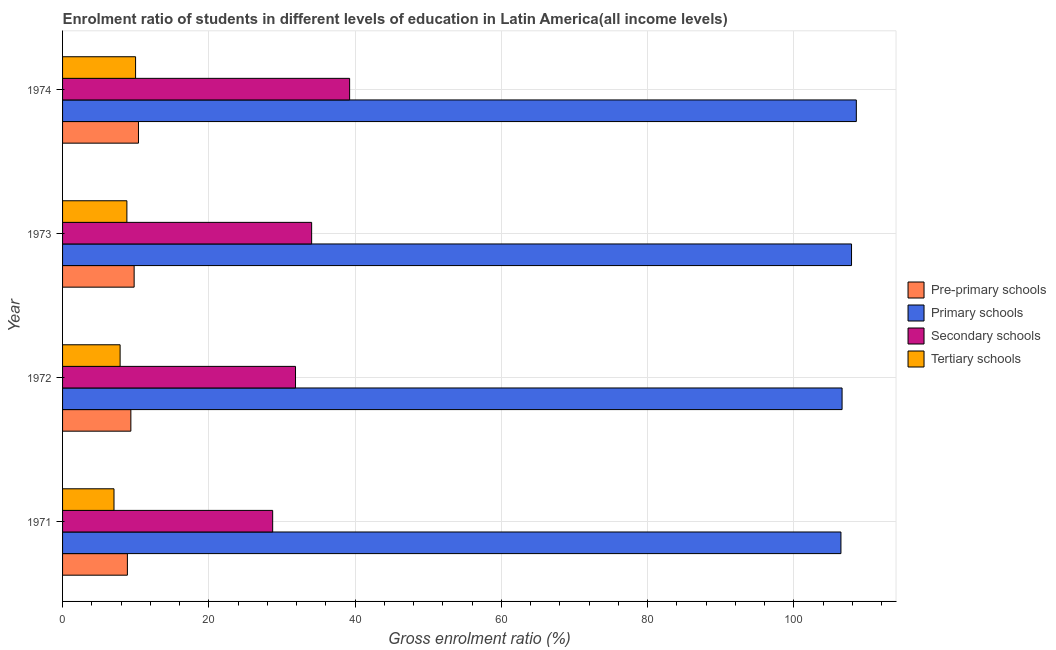How many different coloured bars are there?
Ensure brevity in your answer.  4. Are the number of bars per tick equal to the number of legend labels?
Give a very brief answer. Yes. Are the number of bars on each tick of the Y-axis equal?
Your answer should be compact. Yes. What is the label of the 1st group of bars from the top?
Ensure brevity in your answer.  1974. What is the gross enrolment ratio in pre-primary schools in 1972?
Offer a very short reply. 9.34. Across all years, what is the maximum gross enrolment ratio in tertiary schools?
Provide a succinct answer. 9.98. Across all years, what is the minimum gross enrolment ratio in pre-primary schools?
Provide a succinct answer. 8.86. In which year was the gross enrolment ratio in pre-primary schools maximum?
Your answer should be compact. 1974. In which year was the gross enrolment ratio in tertiary schools minimum?
Offer a terse response. 1971. What is the total gross enrolment ratio in primary schools in the graph?
Offer a terse response. 429.39. What is the difference between the gross enrolment ratio in pre-primary schools in 1972 and that in 1973?
Make the answer very short. -0.45. What is the difference between the gross enrolment ratio in tertiary schools in 1972 and the gross enrolment ratio in primary schools in 1971?
Provide a short and direct response. -98.55. What is the average gross enrolment ratio in pre-primary schools per year?
Offer a very short reply. 9.59. In the year 1973, what is the difference between the gross enrolment ratio in secondary schools and gross enrolment ratio in tertiary schools?
Provide a short and direct response. 25.26. In how many years, is the gross enrolment ratio in secondary schools greater than 56 %?
Your answer should be very brief. 0. Is the gross enrolment ratio in secondary schools in 1971 less than that in 1973?
Make the answer very short. Yes. What is the difference between the highest and the second highest gross enrolment ratio in secondary schools?
Your answer should be compact. 5.19. What is the difference between the highest and the lowest gross enrolment ratio in tertiary schools?
Make the answer very short. 2.95. In how many years, is the gross enrolment ratio in pre-primary schools greater than the average gross enrolment ratio in pre-primary schools taken over all years?
Offer a terse response. 2. Is the sum of the gross enrolment ratio in primary schools in 1971 and 1973 greater than the maximum gross enrolment ratio in pre-primary schools across all years?
Offer a terse response. Yes. What does the 3rd bar from the top in 1972 represents?
Make the answer very short. Primary schools. What does the 2nd bar from the bottom in 1973 represents?
Give a very brief answer. Primary schools. Is it the case that in every year, the sum of the gross enrolment ratio in pre-primary schools and gross enrolment ratio in primary schools is greater than the gross enrolment ratio in secondary schools?
Ensure brevity in your answer.  Yes. What is the difference between two consecutive major ticks on the X-axis?
Offer a very short reply. 20. Are the values on the major ticks of X-axis written in scientific E-notation?
Your answer should be compact. No. Does the graph contain any zero values?
Your answer should be compact. No. Does the graph contain grids?
Offer a terse response. Yes. Where does the legend appear in the graph?
Provide a succinct answer. Center right. How many legend labels are there?
Your response must be concise. 4. How are the legend labels stacked?
Your answer should be very brief. Vertical. What is the title of the graph?
Keep it short and to the point. Enrolment ratio of students in different levels of education in Latin America(all income levels). Does "Public resource use" appear as one of the legend labels in the graph?
Make the answer very short. No. What is the label or title of the X-axis?
Your response must be concise. Gross enrolment ratio (%). What is the Gross enrolment ratio (%) in Pre-primary schools in 1971?
Ensure brevity in your answer.  8.86. What is the Gross enrolment ratio (%) in Primary schools in 1971?
Your answer should be compact. 106.42. What is the Gross enrolment ratio (%) in Secondary schools in 1971?
Your answer should be very brief. 28.73. What is the Gross enrolment ratio (%) in Tertiary schools in 1971?
Make the answer very short. 7.03. What is the Gross enrolment ratio (%) of Pre-primary schools in 1972?
Ensure brevity in your answer.  9.34. What is the Gross enrolment ratio (%) in Primary schools in 1972?
Provide a short and direct response. 106.58. What is the Gross enrolment ratio (%) in Secondary schools in 1972?
Offer a very short reply. 31.85. What is the Gross enrolment ratio (%) of Tertiary schools in 1972?
Your answer should be very brief. 7.87. What is the Gross enrolment ratio (%) of Pre-primary schools in 1973?
Your answer should be compact. 9.79. What is the Gross enrolment ratio (%) of Primary schools in 1973?
Provide a short and direct response. 107.87. What is the Gross enrolment ratio (%) in Secondary schools in 1973?
Make the answer very short. 34.05. What is the Gross enrolment ratio (%) of Tertiary schools in 1973?
Provide a short and direct response. 8.79. What is the Gross enrolment ratio (%) of Pre-primary schools in 1974?
Give a very brief answer. 10.38. What is the Gross enrolment ratio (%) of Primary schools in 1974?
Your answer should be very brief. 108.52. What is the Gross enrolment ratio (%) of Secondary schools in 1974?
Provide a succinct answer. 39.25. What is the Gross enrolment ratio (%) of Tertiary schools in 1974?
Offer a terse response. 9.98. Across all years, what is the maximum Gross enrolment ratio (%) in Pre-primary schools?
Make the answer very short. 10.38. Across all years, what is the maximum Gross enrolment ratio (%) of Primary schools?
Ensure brevity in your answer.  108.52. Across all years, what is the maximum Gross enrolment ratio (%) of Secondary schools?
Your response must be concise. 39.25. Across all years, what is the maximum Gross enrolment ratio (%) of Tertiary schools?
Offer a very short reply. 9.98. Across all years, what is the minimum Gross enrolment ratio (%) of Pre-primary schools?
Provide a succinct answer. 8.86. Across all years, what is the minimum Gross enrolment ratio (%) of Primary schools?
Offer a very short reply. 106.42. Across all years, what is the minimum Gross enrolment ratio (%) in Secondary schools?
Your answer should be compact. 28.73. Across all years, what is the minimum Gross enrolment ratio (%) of Tertiary schools?
Give a very brief answer. 7.03. What is the total Gross enrolment ratio (%) in Pre-primary schools in the graph?
Give a very brief answer. 38.36. What is the total Gross enrolment ratio (%) of Primary schools in the graph?
Ensure brevity in your answer.  429.39. What is the total Gross enrolment ratio (%) in Secondary schools in the graph?
Keep it short and to the point. 133.88. What is the total Gross enrolment ratio (%) of Tertiary schools in the graph?
Make the answer very short. 33.68. What is the difference between the Gross enrolment ratio (%) in Pre-primary schools in 1971 and that in 1972?
Make the answer very short. -0.47. What is the difference between the Gross enrolment ratio (%) of Primary schools in 1971 and that in 1972?
Keep it short and to the point. -0.16. What is the difference between the Gross enrolment ratio (%) in Secondary schools in 1971 and that in 1972?
Ensure brevity in your answer.  -3.12. What is the difference between the Gross enrolment ratio (%) of Tertiary schools in 1971 and that in 1972?
Keep it short and to the point. -0.84. What is the difference between the Gross enrolment ratio (%) of Pre-primary schools in 1971 and that in 1973?
Your response must be concise. -0.92. What is the difference between the Gross enrolment ratio (%) in Primary schools in 1971 and that in 1973?
Offer a terse response. -1.45. What is the difference between the Gross enrolment ratio (%) of Secondary schools in 1971 and that in 1973?
Provide a short and direct response. -5.33. What is the difference between the Gross enrolment ratio (%) in Tertiary schools in 1971 and that in 1973?
Provide a succinct answer. -1.76. What is the difference between the Gross enrolment ratio (%) of Pre-primary schools in 1971 and that in 1974?
Offer a very short reply. -1.51. What is the difference between the Gross enrolment ratio (%) in Primary schools in 1971 and that in 1974?
Ensure brevity in your answer.  -2.1. What is the difference between the Gross enrolment ratio (%) in Secondary schools in 1971 and that in 1974?
Give a very brief answer. -10.52. What is the difference between the Gross enrolment ratio (%) of Tertiary schools in 1971 and that in 1974?
Keep it short and to the point. -2.95. What is the difference between the Gross enrolment ratio (%) of Pre-primary schools in 1972 and that in 1973?
Ensure brevity in your answer.  -0.45. What is the difference between the Gross enrolment ratio (%) of Primary schools in 1972 and that in 1973?
Provide a succinct answer. -1.29. What is the difference between the Gross enrolment ratio (%) of Secondary schools in 1972 and that in 1973?
Provide a short and direct response. -2.2. What is the difference between the Gross enrolment ratio (%) of Tertiary schools in 1972 and that in 1973?
Offer a terse response. -0.93. What is the difference between the Gross enrolment ratio (%) in Pre-primary schools in 1972 and that in 1974?
Keep it short and to the point. -1.04. What is the difference between the Gross enrolment ratio (%) of Primary schools in 1972 and that in 1974?
Offer a very short reply. -1.95. What is the difference between the Gross enrolment ratio (%) of Secondary schools in 1972 and that in 1974?
Offer a terse response. -7.4. What is the difference between the Gross enrolment ratio (%) of Tertiary schools in 1972 and that in 1974?
Keep it short and to the point. -2.12. What is the difference between the Gross enrolment ratio (%) in Pre-primary schools in 1973 and that in 1974?
Keep it short and to the point. -0.59. What is the difference between the Gross enrolment ratio (%) in Primary schools in 1973 and that in 1974?
Keep it short and to the point. -0.66. What is the difference between the Gross enrolment ratio (%) in Secondary schools in 1973 and that in 1974?
Give a very brief answer. -5.19. What is the difference between the Gross enrolment ratio (%) in Tertiary schools in 1973 and that in 1974?
Offer a terse response. -1.19. What is the difference between the Gross enrolment ratio (%) of Pre-primary schools in 1971 and the Gross enrolment ratio (%) of Primary schools in 1972?
Keep it short and to the point. -97.71. What is the difference between the Gross enrolment ratio (%) of Pre-primary schools in 1971 and the Gross enrolment ratio (%) of Secondary schools in 1972?
Your answer should be compact. -22.99. What is the difference between the Gross enrolment ratio (%) in Primary schools in 1971 and the Gross enrolment ratio (%) in Secondary schools in 1972?
Offer a terse response. 74.57. What is the difference between the Gross enrolment ratio (%) in Primary schools in 1971 and the Gross enrolment ratio (%) in Tertiary schools in 1972?
Provide a short and direct response. 98.55. What is the difference between the Gross enrolment ratio (%) in Secondary schools in 1971 and the Gross enrolment ratio (%) in Tertiary schools in 1972?
Your answer should be very brief. 20.86. What is the difference between the Gross enrolment ratio (%) of Pre-primary schools in 1971 and the Gross enrolment ratio (%) of Primary schools in 1973?
Make the answer very short. -99. What is the difference between the Gross enrolment ratio (%) of Pre-primary schools in 1971 and the Gross enrolment ratio (%) of Secondary schools in 1973?
Give a very brief answer. -25.19. What is the difference between the Gross enrolment ratio (%) of Pre-primary schools in 1971 and the Gross enrolment ratio (%) of Tertiary schools in 1973?
Ensure brevity in your answer.  0.07. What is the difference between the Gross enrolment ratio (%) in Primary schools in 1971 and the Gross enrolment ratio (%) in Secondary schools in 1973?
Ensure brevity in your answer.  72.37. What is the difference between the Gross enrolment ratio (%) of Primary schools in 1971 and the Gross enrolment ratio (%) of Tertiary schools in 1973?
Your answer should be very brief. 97.63. What is the difference between the Gross enrolment ratio (%) of Secondary schools in 1971 and the Gross enrolment ratio (%) of Tertiary schools in 1973?
Offer a very short reply. 19.93. What is the difference between the Gross enrolment ratio (%) of Pre-primary schools in 1971 and the Gross enrolment ratio (%) of Primary schools in 1974?
Your answer should be very brief. -99.66. What is the difference between the Gross enrolment ratio (%) in Pre-primary schools in 1971 and the Gross enrolment ratio (%) in Secondary schools in 1974?
Make the answer very short. -30.38. What is the difference between the Gross enrolment ratio (%) of Pre-primary schools in 1971 and the Gross enrolment ratio (%) of Tertiary schools in 1974?
Offer a terse response. -1.12. What is the difference between the Gross enrolment ratio (%) in Primary schools in 1971 and the Gross enrolment ratio (%) in Secondary schools in 1974?
Ensure brevity in your answer.  67.17. What is the difference between the Gross enrolment ratio (%) in Primary schools in 1971 and the Gross enrolment ratio (%) in Tertiary schools in 1974?
Your response must be concise. 96.44. What is the difference between the Gross enrolment ratio (%) in Secondary schools in 1971 and the Gross enrolment ratio (%) in Tertiary schools in 1974?
Offer a terse response. 18.74. What is the difference between the Gross enrolment ratio (%) of Pre-primary schools in 1972 and the Gross enrolment ratio (%) of Primary schools in 1973?
Offer a very short reply. -98.53. What is the difference between the Gross enrolment ratio (%) of Pre-primary schools in 1972 and the Gross enrolment ratio (%) of Secondary schools in 1973?
Offer a very short reply. -24.72. What is the difference between the Gross enrolment ratio (%) in Pre-primary schools in 1972 and the Gross enrolment ratio (%) in Tertiary schools in 1973?
Your answer should be compact. 0.54. What is the difference between the Gross enrolment ratio (%) in Primary schools in 1972 and the Gross enrolment ratio (%) in Secondary schools in 1973?
Give a very brief answer. 72.52. What is the difference between the Gross enrolment ratio (%) of Primary schools in 1972 and the Gross enrolment ratio (%) of Tertiary schools in 1973?
Keep it short and to the point. 97.78. What is the difference between the Gross enrolment ratio (%) in Secondary schools in 1972 and the Gross enrolment ratio (%) in Tertiary schools in 1973?
Your response must be concise. 23.05. What is the difference between the Gross enrolment ratio (%) in Pre-primary schools in 1972 and the Gross enrolment ratio (%) in Primary schools in 1974?
Ensure brevity in your answer.  -99.19. What is the difference between the Gross enrolment ratio (%) of Pre-primary schools in 1972 and the Gross enrolment ratio (%) of Secondary schools in 1974?
Offer a very short reply. -29.91. What is the difference between the Gross enrolment ratio (%) in Pre-primary schools in 1972 and the Gross enrolment ratio (%) in Tertiary schools in 1974?
Offer a terse response. -0.65. What is the difference between the Gross enrolment ratio (%) in Primary schools in 1972 and the Gross enrolment ratio (%) in Secondary schools in 1974?
Offer a terse response. 67.33. What is the difference between the Gross enrolment ratio (%) in Primary schools in 1972 and the Gross enrolment ratio (%) in Tertiary schools in 1974?
Your answer should be very brief. 96.59. What is the difference between the Gross enrolment ratio (%) in Secondary schools in 1972 and the Gross enrolment ratio (%) in Tertiary schools in 1974?
Your answer should be very brief. 21.87. What is the difference between the Gross enrolment ratio (%) of Pre-primary schools in 1973 and the Gross enrolment ratio (%) of Primary schools in 1974?
Offer a very short reply. -98.74. What is the difference between the Gross enrolment ratio (%) in Pre-primary schools in 1973 and the Gross enrolment ratio (%) in Secondary schools in 1974?
Give a very brief answer. -29.46. What is the difference between the Gross enrolment ratio (%) in Pre-primary schools in 1973 and the Gross enrolment ratio (%) in Tertiary schools in 1974?
Provide a succinct answer. -0.2. What is the difference between the Gross enrolment ratio (%) in Primary schools in 1973 and the Gross enrolment ratio (%) in Secondary schools in 1974?
Provide a succinct answer. 68.62. What is the difference between the Gross enrolment ratio (%) in Primary schools in 1973 and the Gross enrolment ratio (%) in Tertiary schools in 1974?
Provide a short and direct response. 97.89. What is the difference between the Gross enrolment ratio (%) in Secondary schools in 1973 and the Gross enrolment ratio (%) in Tertiary schools in 1974?
Ensure brevity in your answer.  24.07. What is the average Gross enrolment ratio (%) of Pre-primary schools per year?
Ensure brevity in your answer.  9.59. What is the average Gross enrolment ratio (%) of Primary schools per year?
Keep it short and to the point. 107.35. What is the average Gross enrolment ratio (%) of Secondary schools per year?
Provide a short and direct response. 33.47. What is the average Gross enrolment ratio (%) in Tertiary schools per year?
Your response must be concise. 8.42. In the year 1971, what is the difference between the Gross enrolment ratio (%) in Pre-primary schools and Gross enrolment ratio (%) in Primary schools?
Provide a short and direct response. -97.56. In the year 1971, what is the difference between the Gross enrolment ratio (%) in Pre-primary schools and Gross enrolment ratio (%) in Secondary schools?
Your answer should be very brief. -19.86. In the year 1971, what is the difference between the Gross enrolment ratio (%) of Pre-primary schools and Gross enrolment ratio (%) of Tertiary schools?
Provide a succinct answer. 1.83. In the year 1971, what is the difference between the Gross enrolment ratio (%) of Primary schools and Gross enrolment ratio (%) of Secondary schools?
Provide a succinct answer. 77.69. In the year 1971, what is the difference between the Gross enrolment ratio (%) of Primary schools and Gross enrolment ratio (%) of Tertiary schools?
Your response must be concise. 99.39. In the year 1971, what is the difference between the Gross enrolment ratio (%) in Secondary schools and Gross enrolment ratio (%) in Tertiary schools?
Provide a succinct answer. 21.69. In the year 1972, what is the difference between the Gross enrolment ratio (%) of Pre-primary schools and Gross enrolment ratio (%) of Primary schools?
Give a very brief answer. -97.24. In the year 1972, what is the difference between the Gross enrolment ratio (%) of Pre-primary schools and Gross enrolment ratio (%) of Secondary schools?
Make the answer very short. -22.51. In the year 1972, what is the difference between the Gross enrolment ratio (%) in Pre-primary schools and Gross enrolment ratio (%) in Tertiary schools?
Provide a succinct answer. 1.47. In the year 1972, what is the difference between the Gross enrolment ratio (%) of Primary schools and Gross enrolment ratio (%) of Secondary schools?
Your answer should be compact. 74.73. In the year 1972, what is the difference between the Gross enrolment ratio (%) in Primary schools and Gross enrolment ratio (%) in Tertiary schools?
Ensure brevity in your answer.  98.71. In the year 1972, what is the difference between the Gross enrolment ratio (%) in Secondary schools and Gross enrolment ratio (%) in Tertiary schools?
Provide a succinct answer. 23.98. In the year 1973, what is the difference between the Gross enrolment ratio (%) of Pre-primary schools and Gross enrolment ratio (%) of Primary schools?
Give a very brief answer. -98.08. In the year 1973, what is the difference between the Gross enrolment ratio (%) in Pre-primary schools and Gross enrolment ratio (%) in Secondary schools?
Provide a short and direct response. -24.27. In the year 1973, what is the difference between the Gross enrolment ratio (%) in Primary schools and Gross enrolment ratio (%) in Secondary schools?
Your answer should be very brief. 73.82. In the year 1973, what is the difference between the Gross enrolment ratio (%) in Primary schools and Gross enrolment ratio (%) in Tertiary schools?
Offer a terse response. 99.07. In the year 1973, what is the difference between the Gross enrolment ratio (%) of Secondary schools and Gross enrolment ratio (%) of Tertiary schools?
Make the answer very short. 25.26. In the year 1974, what is the difference between the Gross enrolment ratio (%) of Pre-primary schools and Gross enrolment ratio (%) of Primary schools?
Offer a terse response. -98.15. In the year 1974, what is the difference between the Gross enrolment ratio (%) of Pre-primary schools and Gross enrolment ratio (%) of Secondary schools?
Provide a short and direct response. -28.87. In the year 1974, what is the difference between the Gross enrolment ratio (%) of Pre-primary schools and Gross enrolment ratio (%) of Tertiary schools?
Ensure brevity in your answer.  0.39. In the year 1974, what is the difference between the Gross enrolment ratio (%) of Primary schools and Gross enrolment ratio (%) of Secondary schools?
Keep it short and to the point. 69.28. In the year 1974, what is the difference between the Gross enrolment ratio (%) of Primary schools and Gross enrolment ratio (%) of Tertiary schools?
Offer a terse response. 98.54. In the year 1974, what is the difference between the Gross enrolment ratio (%) in Secondary schools and Gross enrolment ratio (%) in Tertiary schools?
Give a very brief answer. 29.26. What is the ratio of the Gross enrolment ratio (%) of Pre-primary schools in 1971 to that in 1972?
Make the answer very short. 0.95. What is the ratio of the Gross enrolment ratio (%) of Secondary schools in 1971 to that in 1972?
Provide a succinct answer. 0.9. What is the ratio of the Gross enrolment ratio (%) of Tertiary schools in 1971 to that in 1972?
Provide a short and direct response. 0.89. What is the ratio of the Gross enrolment ratio (%) of Pre-primary schools in 1971 to that in 1973?
Give a very brief answer. 0.91. What is the ratio of the Gross enrolment ratio (%) in Primary schools in 1971 to that in 1973?
Your response must be concise. 0.99. What is the ratio of the Gross enrolment ratio (%) of Secondary schools in 1971 to that in 1973?
Provide a short and direct response. 0.84. What is the ratio of the Gross enrolment ratio (%) in Tertiary schools in 1971 to that in 1973?
Your answer should be compact. 0.8. What is the ratio of the Gross enrolment ratio (%) of Pre-primary schools in 1971 to that in 1974?
Your answer should be compact. 0.85. What is the ratio of the Gross enrolment ratio (%) in Primary schools in 1971 to that in 1974?
Keep it short and to the point. 0.98. What is the ratio of the Gross enrolment ratio (%) in Secondary schools in 1971 to that in 1974?
Your answer should be very brief. 0.73. What is the ratio of the Gross enrolment ratio (%) of Tertiary schools in 1971 to that in 1974?
Offer a terse response. 0.7. What is the ratio of the Gross enrolment ratio (%) in Pre-primary schools in 1972 to that in 1973?
Make the answer very short. 0.95. What is the ratio of the Gross enrolment ratio (%) in Primary schools in 1972 to that in 1973?
Ensure brevity in your answer.  0.99. What is the ratio of the Gross enrolment ratio (%) in Secondary schools in 1972 to that in 1973?
Offer a terse response. 0.94. What is the ratio of the Gross enrolment ratio (%) in Tertiary schools in 1972 to that in 1973?
Keep it short and to the point. 0.89. What is the ratio of the Gross enrolment ratio (%) of Pre-primary schools in 1972 to that in 1974?
Offer a terse response. 0.9. What is the ratio of the Gross enrolment ratio (%) of Primary schools in 1972 to that in 1974?
Your answer should be compact. 0.98. What is the ratio of the Gross enrolment ratio (%) of Secondary schools in 1972 to that in 1974?
Provide a short and direct response. 0.81. What is the ratio of the Gross enrolment ratio (%) in Tertiary schools in 1972 to that in 1974?
Keep it short and to the point. 0.79. What is the ratio of the Gross enrolment ratio (%) of Pre-primary schools in 1973 to that in 1974?
Your answer should be very brief. 0.94. What is the ratio of the Gross enrolment ratio (%) of Secondary schools in 1973 to that in 1974?
Give a very brief answer. 0.87. What is the ratio of the Gross enrolment ratio (%) of Tertiary schools in 1973 to that in 1974?
Your answer should be compact. 0.88. What is the difference between the highest and the second highest Gross enrolment ratio (%) in Pre-primary schools?
Your response must be concise. 0.59. What is the difference between the highest and the second highest Gross enrolment ratio (%) of Primary schools?
Offer a very short reply. 0.66. What is the difference between the highest and the second highest Gross enrolment ratio (%) in Secondary schools?
Your answer should be compact. 5.19. What is the difference between the highest and the second highest Gross enrolment ratio (%) of Tertiary schools?
Your response must be concise. 1.19. What is the difference between the highest and the lowest Gross enrolment ratio (%) in Pre-primary schools?
Ensure brevity in your answer.  1.51. What is the difference between the highest and the lowest Gross enrolment ratio (%) of Primary schools?
Offer a very short reply. 2.1. What is the difference between the highest and the lowest Gross enrolment ratio (%) of Secondary schools?
Keep it short and to the point. 10.52. What is the difference between the highest and the lowest Gross enrolment ratio (%) in Tertiary schools?
Keep it short and to the point. 2.95. 